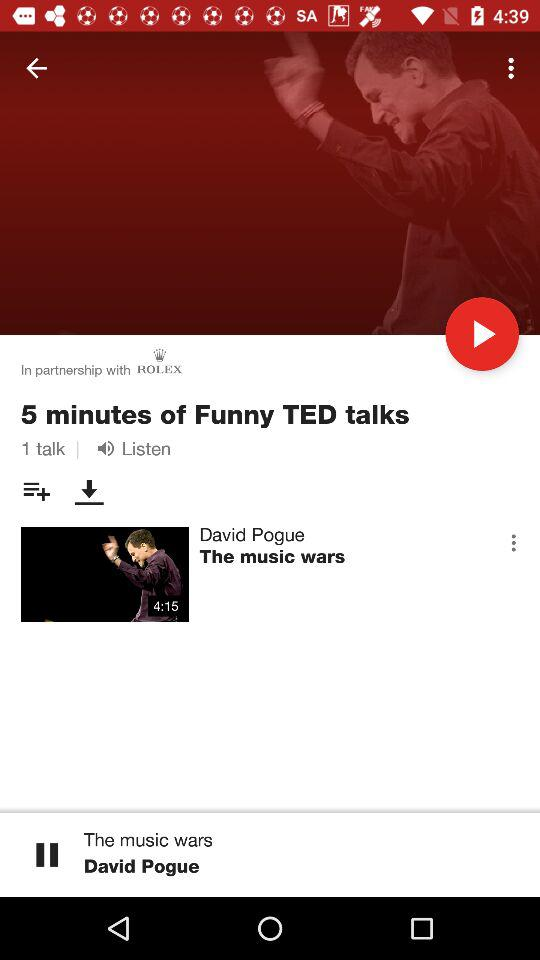What video is currently playing? The currently playing video is "The music wars". 